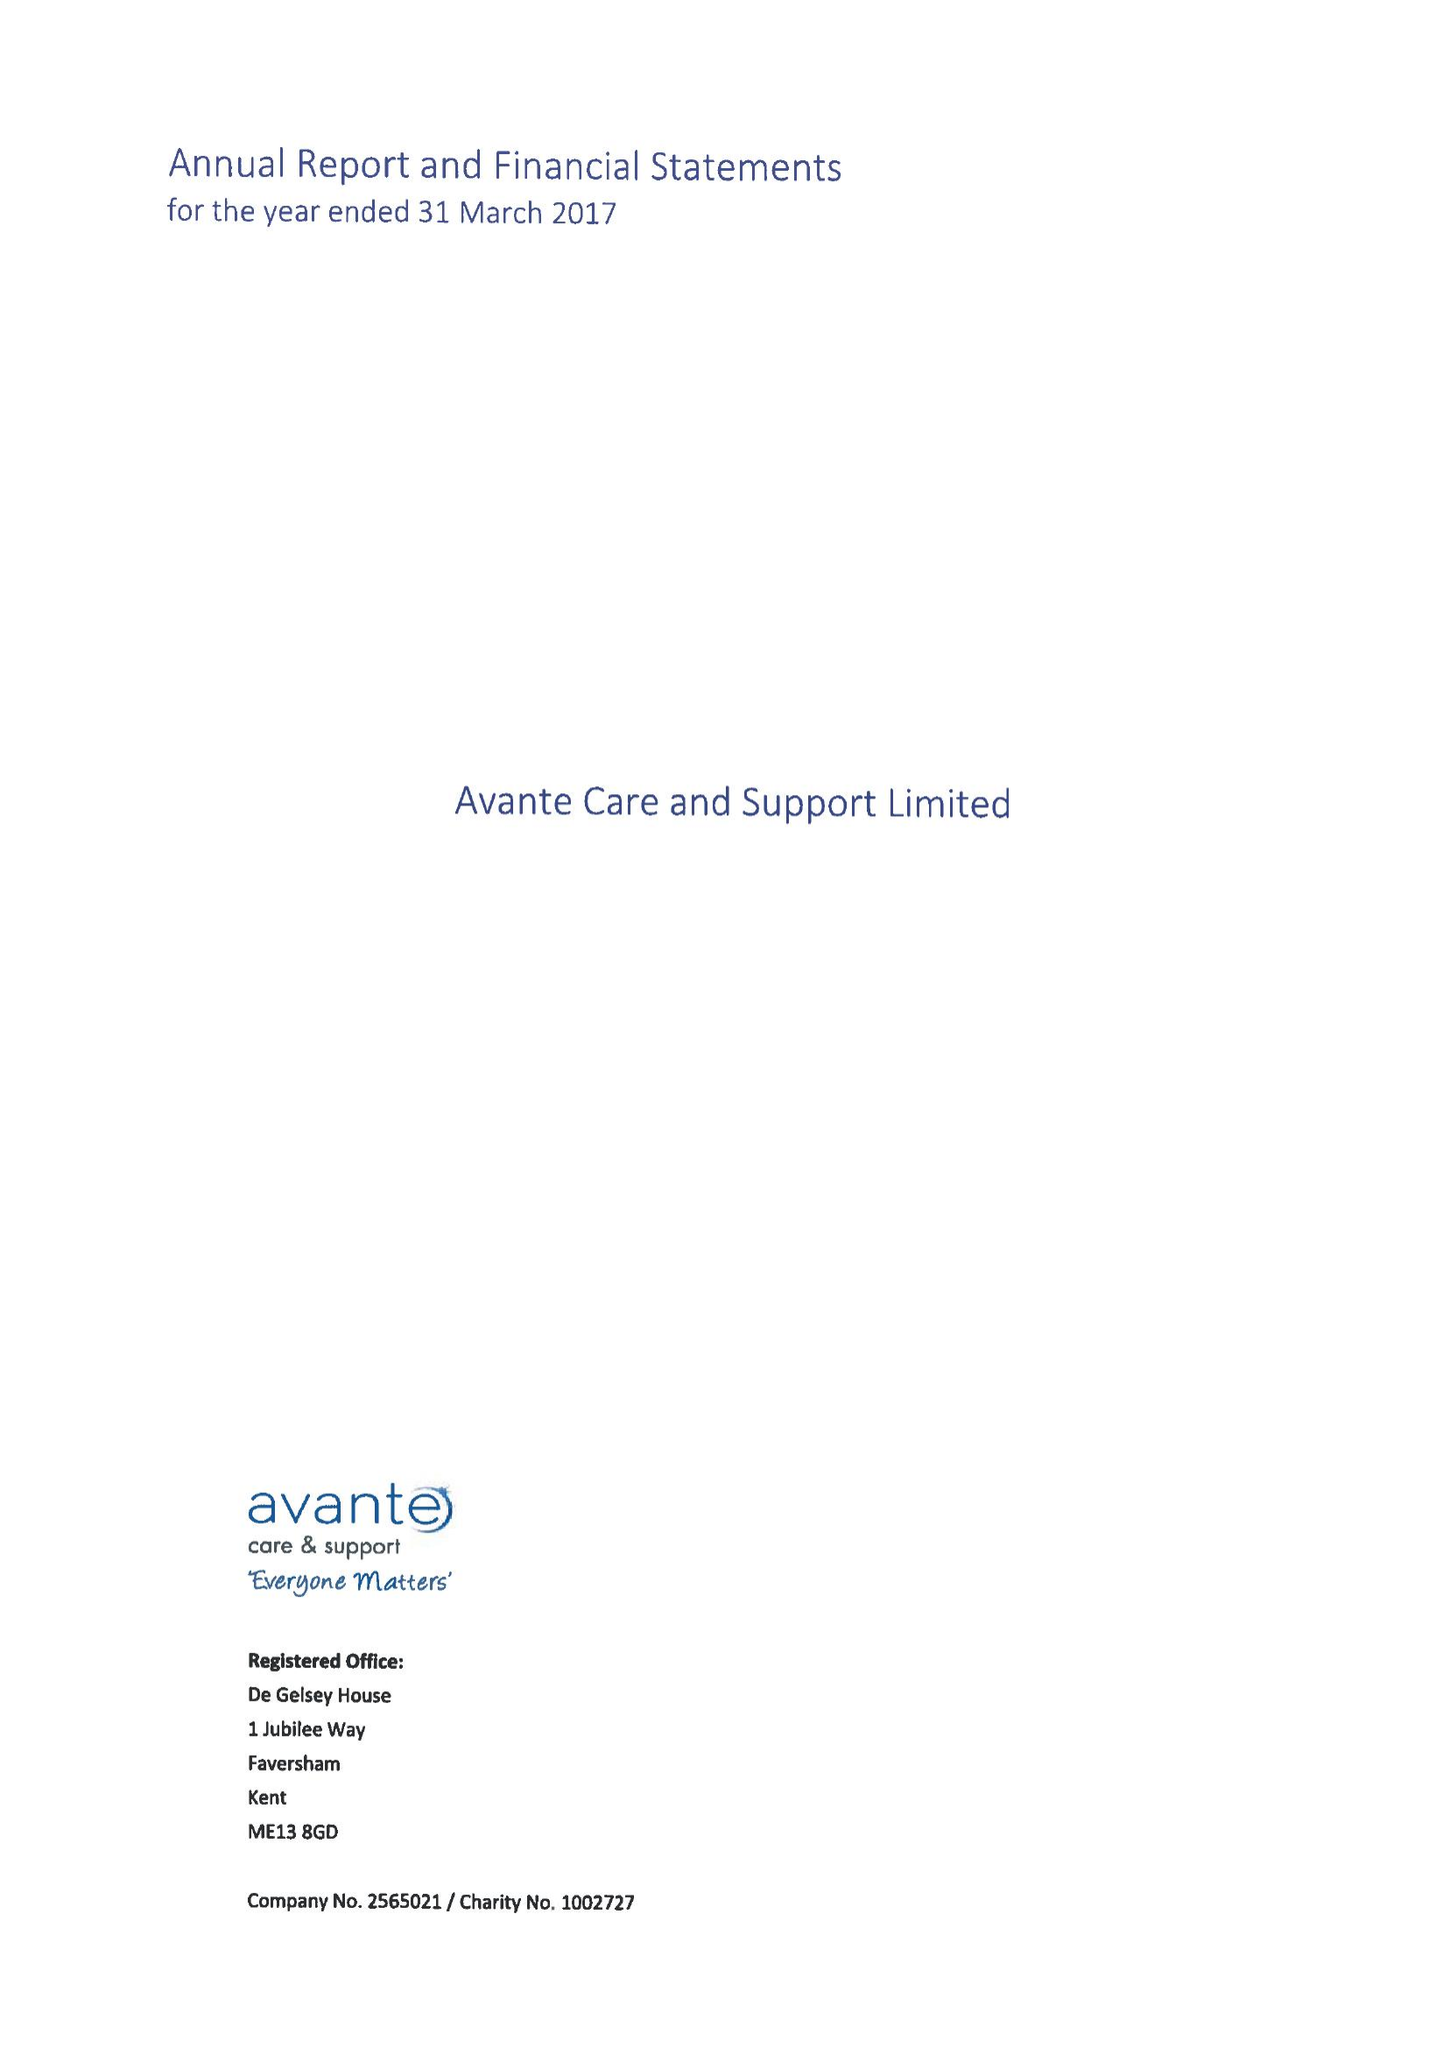What is the value for the charity_number?
Answer the question using a single word or phrase. 1002727 